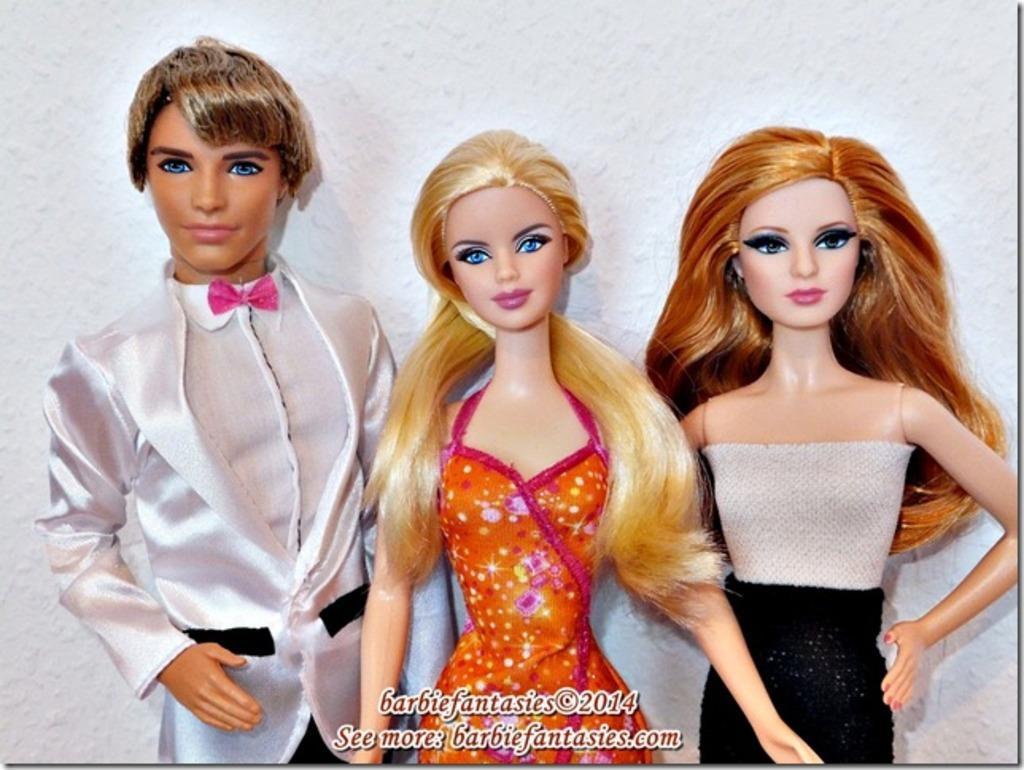How would you summarize this image in a sentence or two? In this image in front there are three dolls. In the background of the image there is a wall and there is some text written at the bottom of the image. 